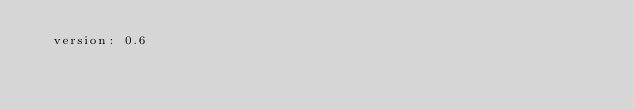Convert code to text. <code><loc_0><loc_0><loc_500><loc_500><_YAML_>  version: 0.6
</code> 